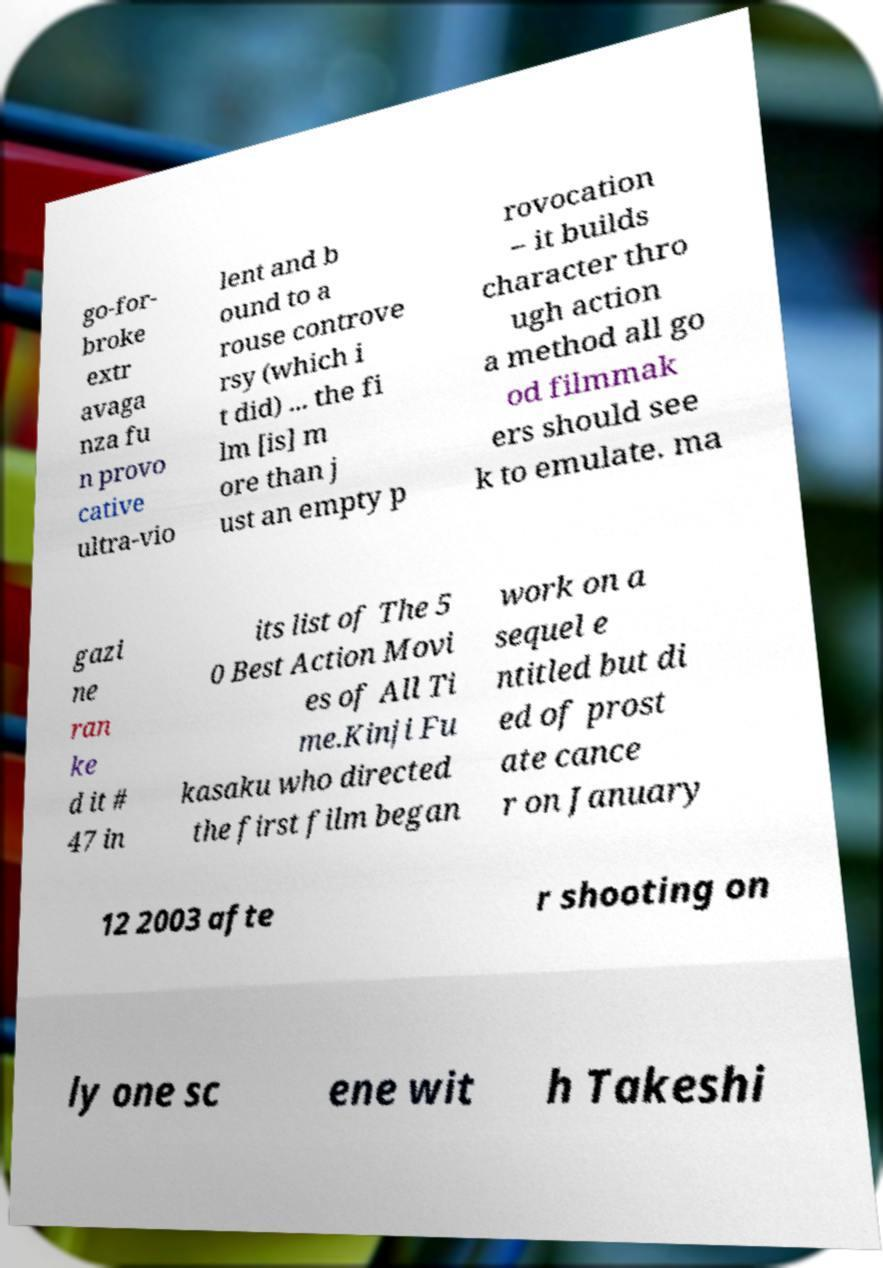There's text embedded in this image that I need extracted. Can you transcribe it verbatim? go-for- broke extr avaga nza fu n provo cative ultra-vio lent and b ound to a rouse controve rsy (which i t did) ... the fi lm [is] m ore than j ust an empty p rovocation – it builds character thro ugh action a method all go od filmmak ers should see k to emulate. ma gazi ne ran ke d it # 47 in its list of The 5 0 Best Action Movi es of All Ti me.Kinji Fu kasaku who directed the first film began work on a sequel e ntitled but di ed of prost ate cance r on January 12 2003 afte r shooting on ly one sc ene wit h Takeshi 